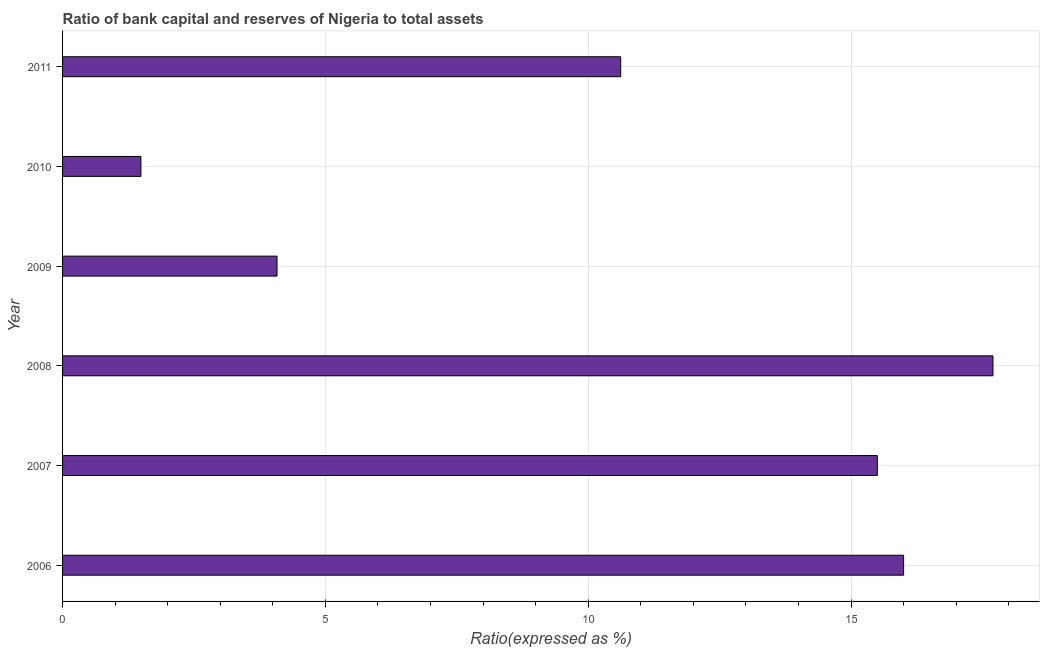Does the graph contain grids?
Ensure brevity in your answer.  Yes. What is the title of the graph?
Provide a short and direct response. Ratio of bank capital and reserves of Nigeria to total assets. What is the label or title of the X-axis?
Your answer should be compact. Ratio(expressed as %). What is the bank capital to assets ratio in 2010?
Provide a short and direct response. 1.49. Across all years, what is the minimum bank capital to assets ratio?
Offer a very short reply. 1.49. In which year was the bank capital to assets ratio maximum?
Your answer should be very brief. 2008. What is the sum of the bank capital to assets ratio?
Give a very brief answer. 65.39. What is the difference between the bank capital to assets ratio in 2008 and 2009?
Provide a short and direct response. 13.62. What is the average bank capital to assets ratio per year?
Your answer should be compact. 10.9. What is the median bank capital to assets ratio?
Provide a succinct answer. 13.06. What is the ratio of the bank capital to assets ratio in 2006 to that in 2010?
Your answer should be compact. 10.73. Is the bank capital to assets ratio in 2007 less than that in 2008?
Offer a very short reply. Yes. Is the sum of the bank capital to assets ratio in 2006 and 2011 greater than the maximum bank capital to assets ratio across all years?
Offer a terse response. Yes. What is the difference between the highest and the lowest bank capital to assets ratio?
Offer a terse response. 16.21. In how many years, is the bank capital to assets ratio greater than the average bank capital to assets ratio taken over all years?
Offer a very short reply. 3. How many bars are there?
Offer a very short reply. 6. What is the difference between two consecutive major ticks on the X-axis?
Give a very brief answer. 5. Are the values on the major ticks of X-axis written in scientific E-notation?
Give a very brief answer. No. What is the Ratio(expressed as %) in 2007?
Ensure brevity in your answer.  15.5. What is the Ratio(expressed as %) of 2009?
Make the answer very short. 4.08. What is the Ratio(expressed as %) of 2010?
Make the answer very short. 1.49. What is the Ratio(expressed as %) of 2011?
Your answer should be compact. 10.62. What is the difference between the Ratio(expressed as %) in 2006 and 2007?
Your answer should be compact. 0.5. What is the difference between the Ratio(expressed as %) in 2006 and 2008?
Provide a short and direct response. -1.7. What is the difference between the Ratio(expressed as %) in 2006 and 2009?
Offer a very short reply. 11.92. What is the difference between the Ratio(expressed as %) in 2006 and 2010?
Your response must be concise. 14.51. What is the difference between the Ratio(expressed as %) in 2006 and 2011?
Offer a terse response. 5.38. What is the difference between the Ratio(expressed as %) in 2007 and 2008?
Your answer should be very brief. -2.2. What is the difference between the Ratio(expressed as %) in 2007 and 2009?
Offer a terse response. 11.42. What is the difference between the Ratio(expressed as %) in 2007 and 2010?
Your response must be concise. 14.01. What is the difference between the Ratio(expressed as %) in 2007 and 2011?
Your response must be concise. 4.88. What is the difference between the Ratio(expressed as %) in 2008 and 2009?
Provide a short and direct response. 13.62. What is the difference between the Ratio(expressed as %) in 2008 and 2010?
Your response must be concise. 16.21. What is the difference between the Ratio(expressed as %) in 2008 and 2011?
Offer a terse response. 7.08. What is the difference between the Ratio(expressed as %) in 2009 and 2010?
Offer a terse response. 2.59. What is the difference between the Ratio(expressed as %) in 2009 and 2011?
Your response must be concise. -6.54. What is the difference between the Ratio(expressed as %) in 2010 and 2011?
Your answer should be very brief. -9.13. What is the ratio of the Ratio(expressed as %) in 2006 to that in 2007?
Give a very brief answer. 1.03. What is the ratio of the Ratio(expressed as %) in 2006 to that in 2008?
Offer a very short reply. 0.9. What is the ratio of the Ratio(expressed as %) in 2006 to that in 2009?
Your answer should be very brief. 3.92. What is the ratio of the Ratio(expressed as %) in 2006 to that in 2010?
Ensure brevity in your answer.  10.73. What is the ratio of the Ratio(expressed as %) in 2006 to that in 2011?
Provide a short and direct response. 1.51. What is the ratio of the Ratio(expressed as %) in 2007 to that in 2008?
Make the answer very short. 0.88. What is the ratio of the Ratio(expressed as %) in 2007 to that in 2009?
Ensure brevity in your answer.  3.8. What is the ratio of the Ratio(expressed as %) in 2007 to that in 2011?
Your answer should be very brief. 1.46. What is the ratio of the Ratio(expressed as %) in 2008 to that in 2009?
Provide a succinct answer. 4.34. What is the ratio of the Ratio(expressed as %) in 2008 to that in 2010?
Provide a succinct answer. 11.88. What is the ratio of the Ratio(expressed as %) in 2008 to that in 2011?
Your response must be concise. 1.67. What is the ratio of the Ratio(expressed as %) in 2009 to that in 2010?
Offer a very short reply. 2.74. What is the ratio of the Ratio(expressed as %) in 2009 to that in 2011?
Make the answer very short. 0.38. What is the ratio of the Ratio(expressed as %) in 2010 to that in 2011?
Your answer should be compact. 0.14. 